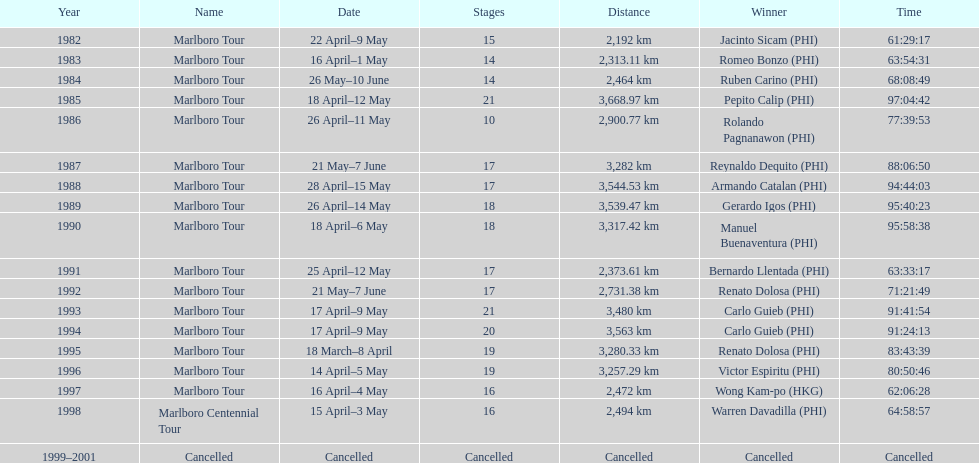During the marlboro tour, what was the maximum distance traveled? 3,668.97 km. 